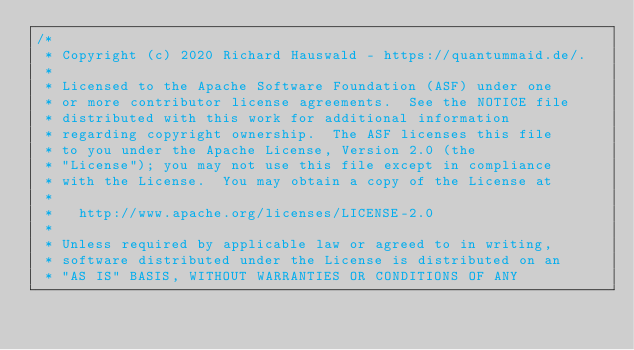Convert code to text. <code><loc_0><loc_0><loc_500><loc_500><_Java_>/*
 * Copyright (c) 2020 Richard Hauswald - https://quantummaid.de/.
 *
 * Licensed to the Apache Software Foundation (ASF) under one
 * or more contributor license agreements.  See the NOTICE file
 * distributed with this work for additional information
 * regarding copyright ownership.  The ASF licenses this file
 * to you under the Apache License, Version 2.0 (the
 * "License"); you may not use this file except in compliance
 * with the License.  You may obtain a copy of the License at
 *
 *   http://www.apache.org/licenses/LICENSE-2.0
 *
 * Unless required by applicable law or agreed to in writing,
 * software distributed under the License is distributed on an
 * "AS IS" BASIS, WITHOUT WARRANTIES OR CONDITIONS OF ANY</code> 